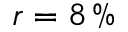Convert formula to latex. <formula><loc_0><loc_0><loc_500><loc_500>r = 8 \, \%</formula> 